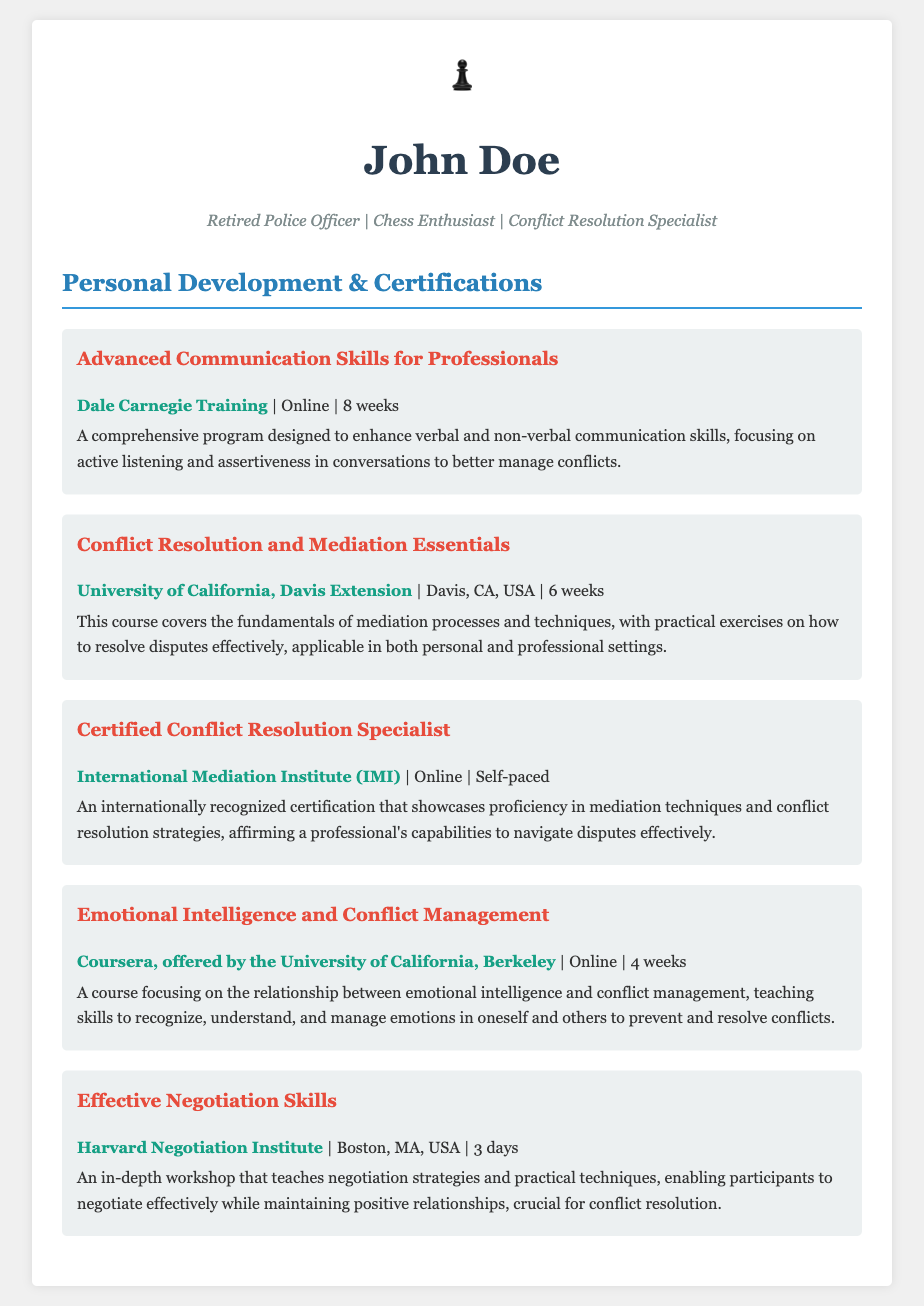What is the title of the course offered by Dale Carnegie Training? The title can be found in the section detailing personal development courses and lists "Advanced Communication Skills for Professionals."
Answer: Advanced Communication Skills for Professionals How long is the course from UC Davis Extension? The course duration is stated in weeks, specifically in the course description for "Conflict Resolution and Mediation Essentials," which is 6 weeks.
Answer: 6 weeks Which institution offers the Certified Conflict Resolution Specialist program? The institution providing this certification is mentioned in the corresponding course description, "International Mediation Institute (IMI)."
Answer: International Mediation Institute (IMI) What is the focus of the course "Emotional Intelligence and Conflict Management"? This focus is detailed in the course description, emphasizing the relationship between emotional intelligence and conflict management.
Answer: Relationship between emotional intelligence and conflict management How many days does the Effective Negotiation Skills workshop last? The duration for this workshop is specified in the course description, which states it lasts for 3 days.
Answer: 3 days What type of program is "Advanced Communication Skills for Professionals"? The course type is mentioned in the course overview as a comprehensive program aimed at enhancing specific skills.
Answer: Comprehensive program What is the main purpose of the course "Conflict Resolution and Mediation Essentials"? The purpose is outlined in the course description to cover the fundamentals of mediation processes and techniques.
Answer: To cover the fundamentals of mediation processes and techniques Is the Certified Conflict Resolution Specialist course self-paced? This information is provided in the certification description which clearly states the course is self-paced.
Answer: Self-paced From which institution is the course "Effective Negotiation Skills" offered? This can be found in the course section, identifying the provider as the "Harvard Negotiation Institute."
Answer: Harvard Negotiation Institute 